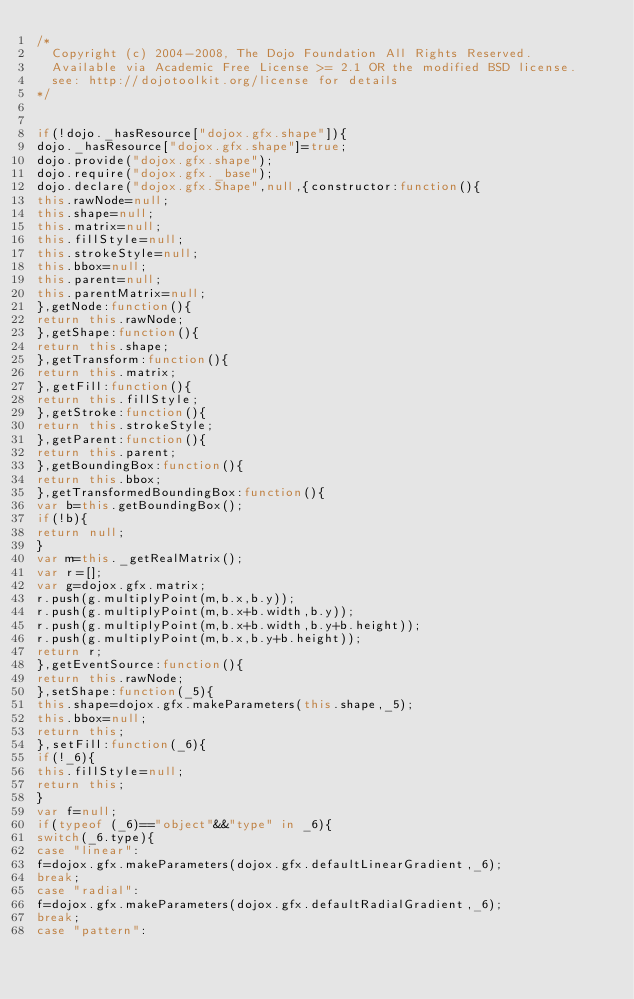<code> <loc_0><loc_0><loc_500><loc_500><_JavaScript_>/*
	Copyright (c) 2004-2008, The Dojo Foundation All Rights Reserved.
	Available via Academic Free License >= 2.1 OR the modified BSD license.
	see: http://dojotoolkit.org/license for details
*/


if(!dojo._hasResource["dojox.gfx.shape"]){
dojo._hasResource["dojox.gfx.shape"]=true;
dojo.provide("dojox.gfx.shape");
dojo.require("dojox.gfx._base");
dojo.declare("dojox.gfx.Shape",null,{constructor:function(){
this.rawNode=null;
this.shape=null;
this.matrix=null;
this.fillStyle=null;
this.strokeStyle=null;
this.bbox=null;
this.parent=null;
this.parentMatrix=null;
},getNode:function(){
return this.rawNode;
},getShape:function(){
return this.shape;
},getTransform:function(){
return this.matrix;
},getFill:function(){
return this.fillStyle;
},getStroke:function(){
return this.strokeStyle;
},getParent:function(){
return this.parent;
},getBoundingBox:function(){
return this.bbox;
},getTransformedBoundingBox:function(){
var b=this.getBoundingBox();
if(!b){
return null;
}
var m=this._getRealMatrix();
var r=[];
var g=dojox.gfx.matrix;
r.push(g.multiplyPoint(m,b.x,b.y));
r.push(g.multiplyPoint(m,b.x+b.width,b.y));
r.push(g.multiplyPoint(m,b.x+b.width,b.y+b.height));
r.push(g.multiplyPoint(m,b.x,b.y+b.height));
return r;
},getEventSource:function(){
return this.rawNode;
},setShape:function(_5){
this.shape=dojox.gfx.makeParameters(this.shape,_5);
this.bbox=null;
return this;
},setFill:function(_6){
if(!_6){
this.fillStyle=null;
return this;
}
var f=null;
if(typeof (_6)=="object"&&"type" in _6){
switch(_6.type){
case "linear":
f=dojox.gfx.makeParameters(dojox.gfx.defaultLinearGradient,_6);
break;
case "radial":
f=dojox.gfx.makeParameters(dojox.gfx.defaultRadialGradient,_6);
break;
case "pattern":</code> 